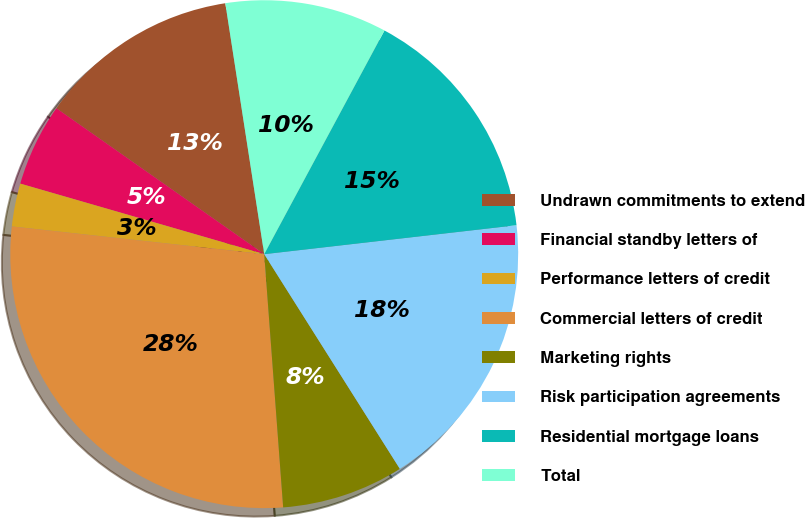Convert chart to OTSL. <chart><loc_0><loc_0><loc_500><loc_500><pie_chart><fcel>Undrawn commitments to extend<fcel>Financial standby letters of<fcel>Performance letters of credit<fcel>Commercial letters of credit<fcel>Marketing rights<fcel>Risk participation agreements<fcel>Residential mortgage loans<fcel>Total<nl><fcel>12.81%<fcel>5.26%<fcel>2.74%<fcel>27.93%<fcel>7.78%<fcel>17.85%<fcel>15.33%<fcel>10.3%<nl></chart> 